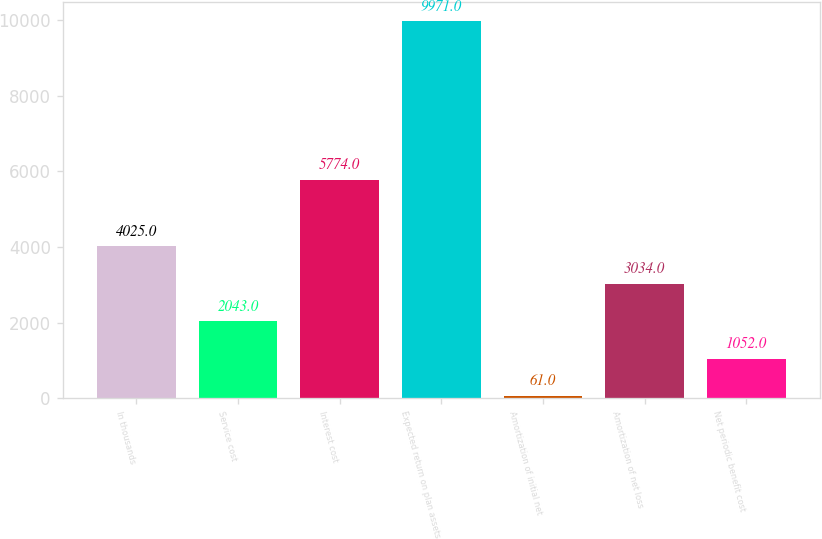<chart> <loc_0><loc_0><loc_500><loc_500><bar_chart><fcel>In thousands<fcel>Service cost<fcel>Interest cost<fcel>Expected return on plan assets<fcel>Amortization of initial net<fcel>Amortization of net loss<fcel>Net periodic benefit cost<nl><fcel>4025<fcel>2043<fcel>5774<fcel>9971<fcel>61<fcel>3034<fcel>1052<nl></chart> 